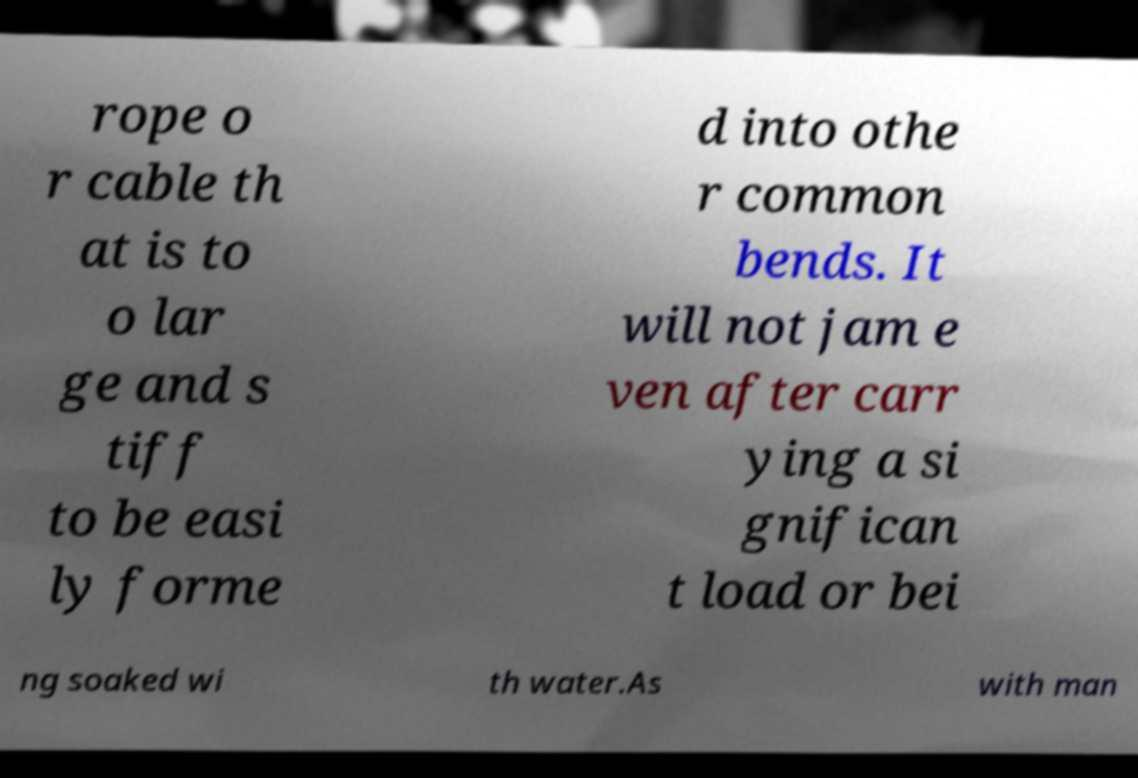I need the written content from this picture converted into text. Can you do that? rope o r cable th at is to o lar ge and s tiff to be easi ly forme d into othe r common bends. It will not jam e ven after carr ying a si gnifican t load or bei ng soaked wi th water.As with man 